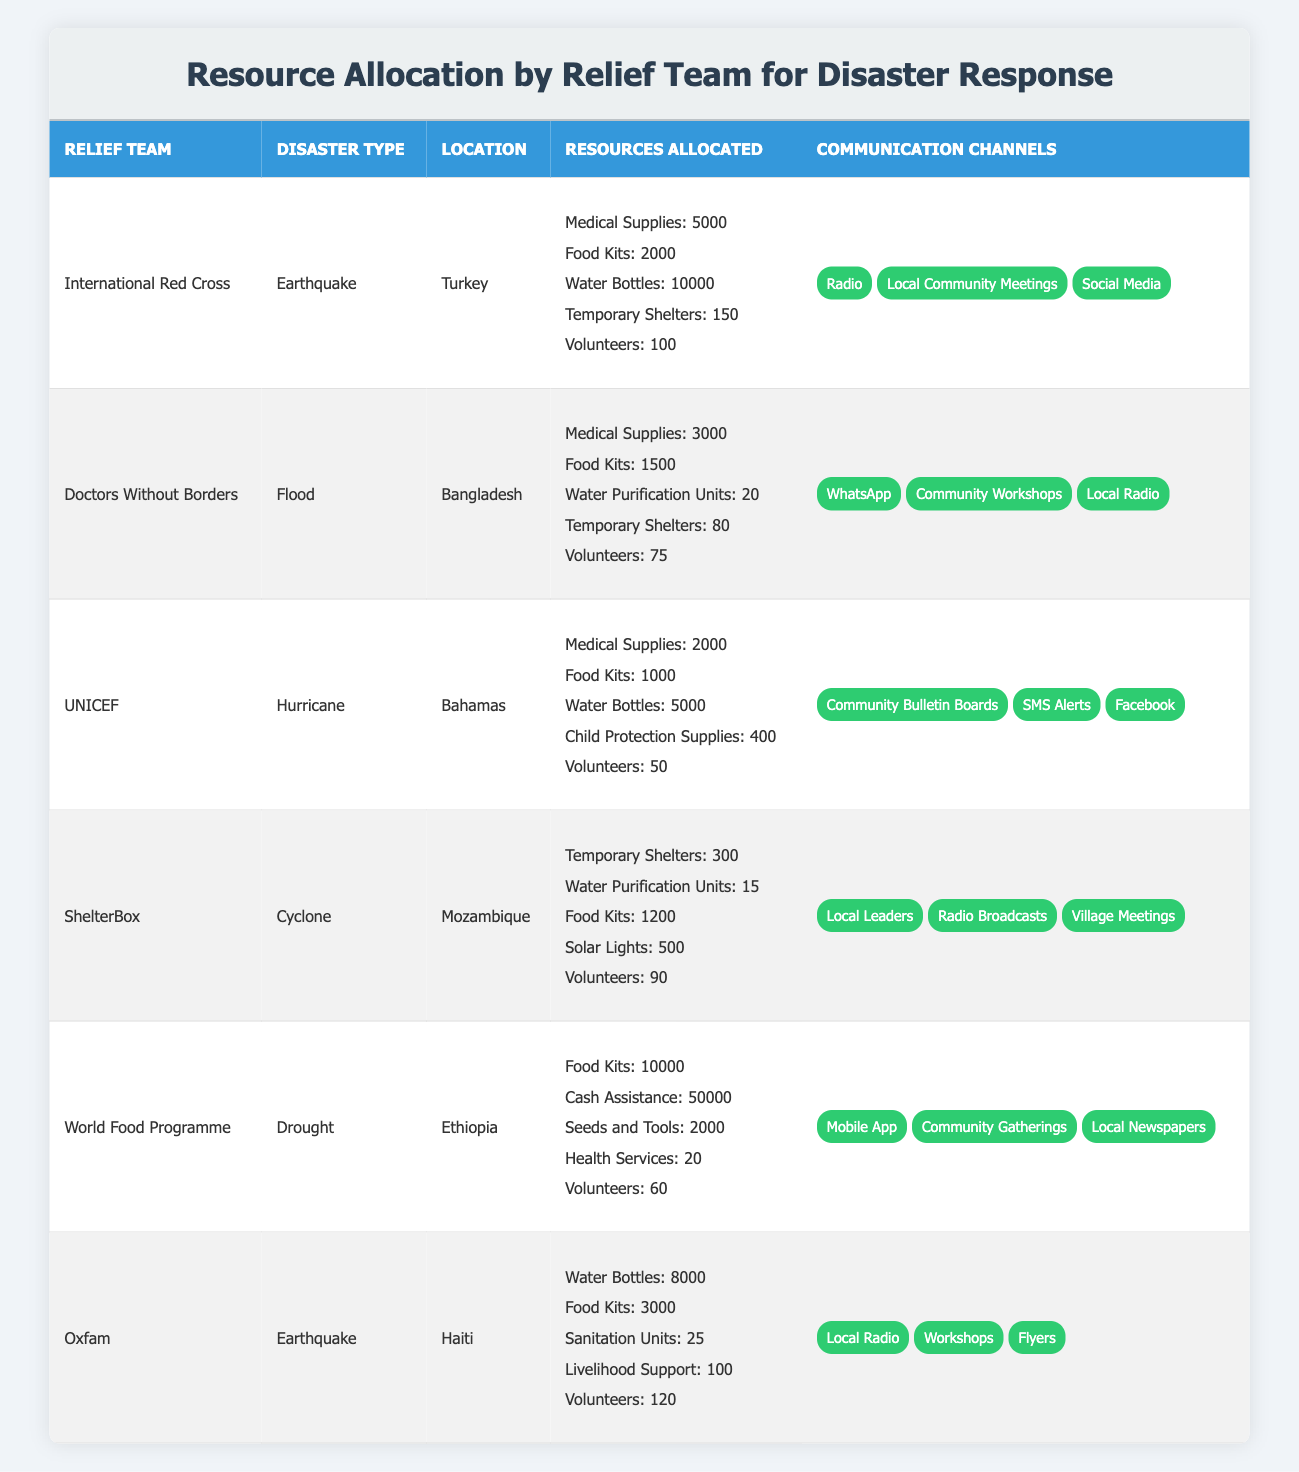What's the total number of Medical Supplies allocated by all relief teams? To find the total Medical Supplies, we look at each relief team that has allocated Medical Supplies: International Red Cross (5000), Doctors Without Borders (3000), UNICEF (2000), and Oxfam (N/A). Adding these values together gives us 5000 + 3000 + 2000 = 10000.
Answer: 10000 Which relief team allocated the most Food Kits? Reviewing the Food Kits allocated by each relief team: International Red Cross (2000), Doctors Without Borders (1500), UNICEF (1000), ShelterBox (1200), World Food Programme (10000), and Oxfam (3000). The maximum is seen with the World Food Programme at 10000.
Answer: World Food Programme Did UNICEF allocate any Water Purification Units? Looking at the table, UNICEF allocated Medical Supplies, Food Kits, Water Bottles, Child Protection Supplies, and Volunteers. Water Purification Units are not listed under UNICEF.
Answer: No How many volunteers did Oxfam and Doctors Without Borders allocate combined? Oxfam allocated 120 volunteers, and Doctors Without Borders allocated 75 volunteers. Adding these two figures gives 120 + 75 = 195 volunteers in total.
Answer: 195 Which disaster type received the highest total in cash assistance, and what was the amount? Cash Assistance is only listed under the World Food Programme for the Drought disaster type, with an allocation of 50000. No other teams or disaster types show this item, hence, it is the highest.
Answer: Drought; 50000 What is the average number of Temporary Shelters allocated by the relief teams involved in earthquake responses? The teams involved in earthquake responses are International Red Cross (150) and Oxfam (N/A). Since Oxfam doesn't allocate Temporary Shelters, we only consider the International Red Cross. Therefore, the average is 150/1 = 150.
Answer: 150 Which disaster had the lowest total allocation of resources? We need to assess the total resources allocated for each disaster. Drought from World Food Programme totals 10000 (Food Kits) + 50000 (Cash Assistance) + 2000 (Seeds and Tools) + 20 (Health Services) + 60 (Volunteers) = 62080. The hurricane total is 2000 + 1000 + 5000 + 400 + 50 = 7450. After comparing different totals, the lowest is for the Hurricane with 7450.
Answer: Hurricane Did any relief team allocate more than 8000 Water Bottles? We see allocations of Water Bottles for International Red Cross (10000) and Oxfam (8000). The value for the International Red Cross exceeds 8000, making the answer yes.
Answer: Yes Which relief team allocated the least number of volunteers, and what was the count? Reviewing the volunteer allocations, we find: International Red Cross (100), Doctors Without Borders (75), UNICEF (50), ShelterBox (90), World Food Programme (60), and Oxfam (120). The lowest number is seen with UNICEF, which allocated 50 volunteers.
Answer: UNICEF; 50 